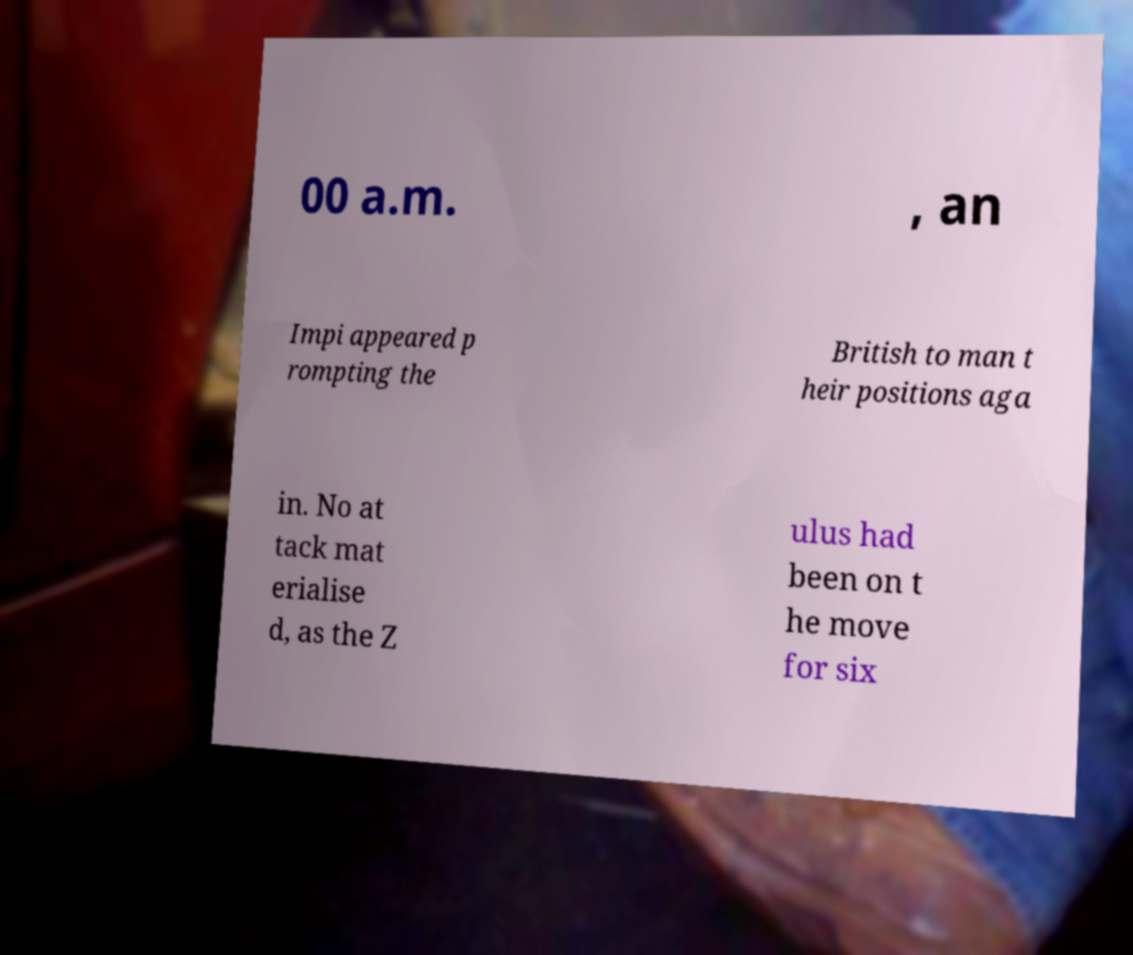There's text embedded in this image that I need extracted. Can you transcribe it verbatim? 00 a.m. , an Impi appeared p rompting the British to man t heir positions aga in. No at tack mat erialise d, as the Z ulus had been on t he move for six 